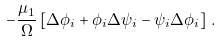<formula> <loc_0><loc_0><loc_500><loc_500>- \frac { \mu _ { 1 } } { \Omega } \left [ \Delta \phi _ { i } + \phi _ { i } \Delta \psi _ { i } - \psi _ { i } \Delta \phi _ { i } \right ] \, .</formula> 